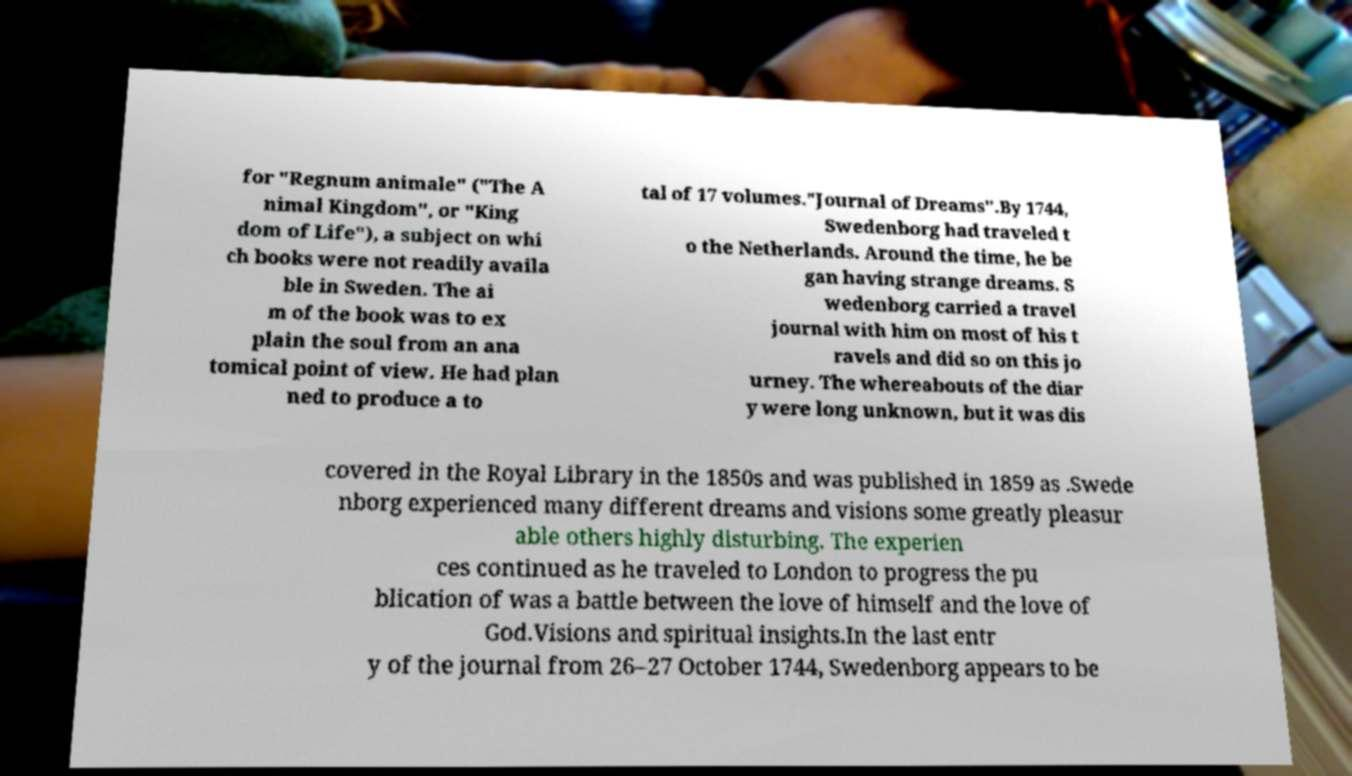For documentation purposes, I need the text within this image transcribed. Could you provide that? for "Regnum animale" ("The A nimal Kingdom", or "King dom of Life"), a subject on whi ch books were not readily availa ble in Sweden. The ai m of the book was to ex plain the soul from an ana tomical point of view. He had plan ned to produce a to tal of 17 volumes."Journal of Dreams".By 1744, Swedenborg had traveled t o the Netherlands. Around the time, he be gan having strange dreams. S wedenborg carried a travel journal with him on most of his t ravels and did so on this jo urney. The whereabouts of the diar y were long unknown, but it was dis covered in the Royal Library in the 1850s and was published in 1859 as .Swede nborg experienced many different dreams and visions some greatly pleasur able others highly disturbing. The experien ces continued as he traveled to London to progress the pu blication of was a battle between the love of himself and the love of God.Visions and spiritual insights.In the last entr y of the journal from 26–27 October 1744, Swedenborg appears to be 